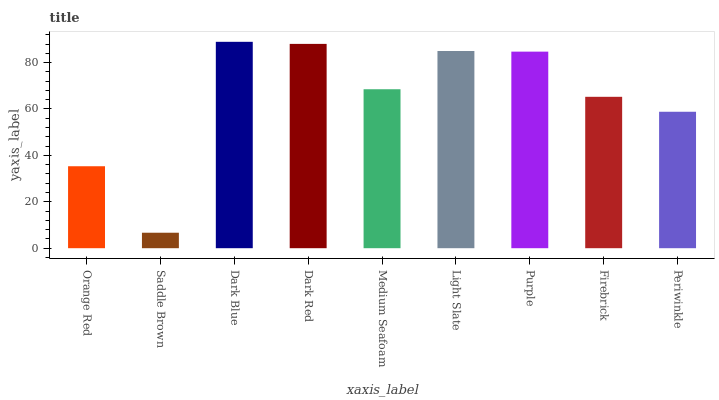Is Saddle Brown the minimum?
Answer yes or no. Yes. Is Dark Blue the maximum?
Answer yes or no. Yes. Is Dark Blue the minimum?
Answer yes or no. No. Is Saddle Brown the maximum?
Answer yes or no. No. Is Dark Blue greater than Saddle Brown?
Answer yes or no. Yes. Is Saddle Brown less than Dark Blue?
Answer yes or no. Yes. Is Saddle Brown greater than Dark Blue?
Answer yes or no. No. Is Dark Blue less than Saddle Brown?
Answer yes or no. No. Is Medium Seafoam the high median?
Answer yes or no. Yes. Is Medium Seafoam the low median?
Answer yes or no. Yes. Is Purple the high median?
Answer yes or no. No. Is Purple the low median?
Answer yes or no. No. 